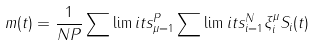Convert formula to latex. <formula><loc_0><loc_0><loc_500><loc_500>m ( t ) = \frac { 1 } { N P } \sum \lim i t s _ { \mu = 1 } ^ { P } \sum \lim i t s _ { i = 1 } ^ { N } \xi _ { i } ^ { \mu } S _ { i } ( t )</formula> 